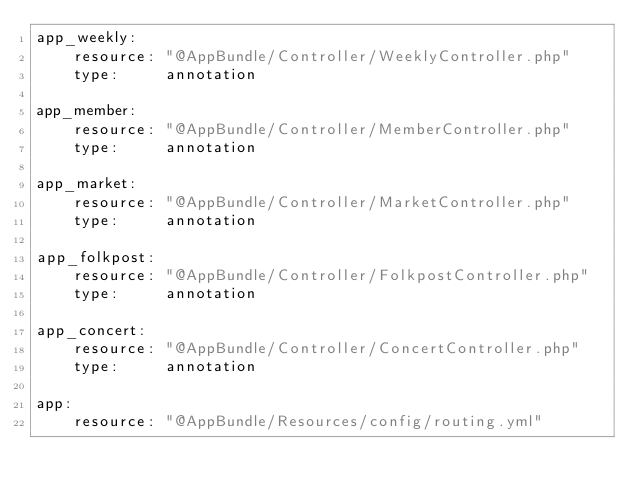Convert code to text. <code><loc_0><loc_0><loc_500><loc_500><_YAML_>app_weekly:
    resource: "@AppBundle/Controller/WeeklyController.php"
    type:     annotation

app_member:
    resource: "@AppBundle/Controller/MemberController.php"
    type:     annotation

app_market:
    resource: "@AppBundle/Controller/MarketController.php"
    type:     annotation

app_folkpost:
    resource: "@AppBundle/Controller/FolkpostController.php"
    type:     annotation

app_concert:
    resource: "@AppBundle/Controller/ConcertController.php"
    type:     annotation

app:
    resource: "@AppBundle/Resources/config/routing.yml"
</code> 